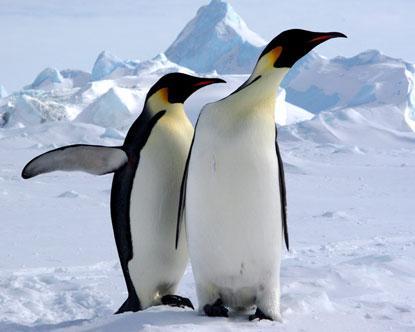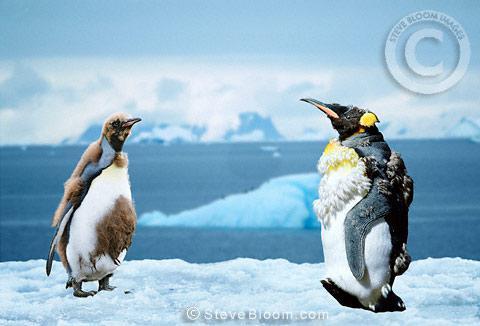The first image is the image on the left, the second image is the image on the right. Evaluate the accuracy of this statement regarding the images: "There are four penguins". Is it true? Answer yes or no. Yes. 